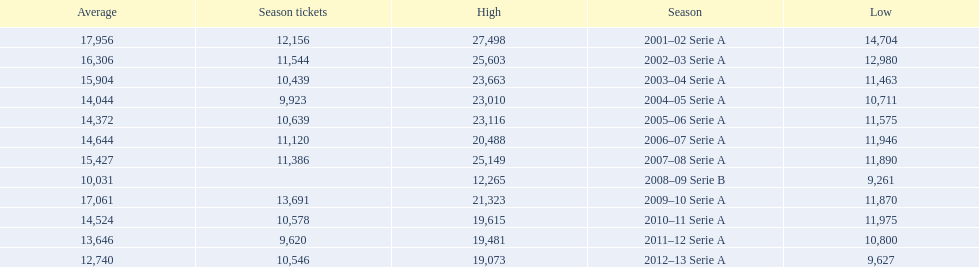What seasons were played at the stadio ennio tardini 2001–02 Serie A, 2002–03 Serie A, 2003–04 Serie A, 2004–05 Serie A, 2005–06 Serie A, 2006–07 Serie A, 2007–08 Serie A, 2008–09 Serie B, 2009–10 Serie A, 2010–11 Serie A, 2011–12 Serie A, 2012–13 Serie A. Which of these seasons had season tickets? 2001–02 Serie A, 2002–03 Serie A, 2003–04 Serie A, 2004–05 Serie A, 2005–06 Serie A, 2006–07 Serie A, 2007–08 Serie A, 2009–10 Serie A, 2010–11 Serie A, 2011–12 Serie A, 2012–13 Serie A. How many season tickets did the 2007-08 season have? 11,386. 